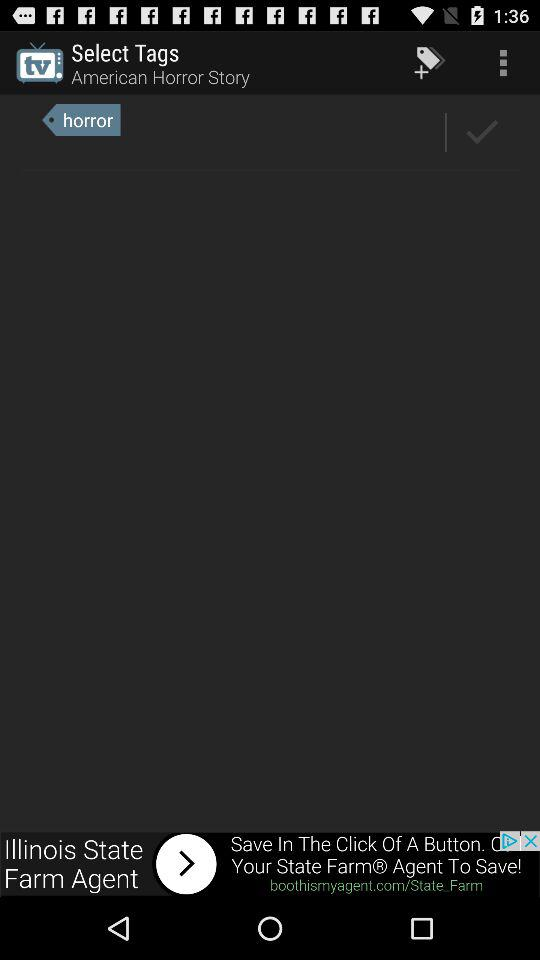What is the selected tag? The selected tag is "horror". 